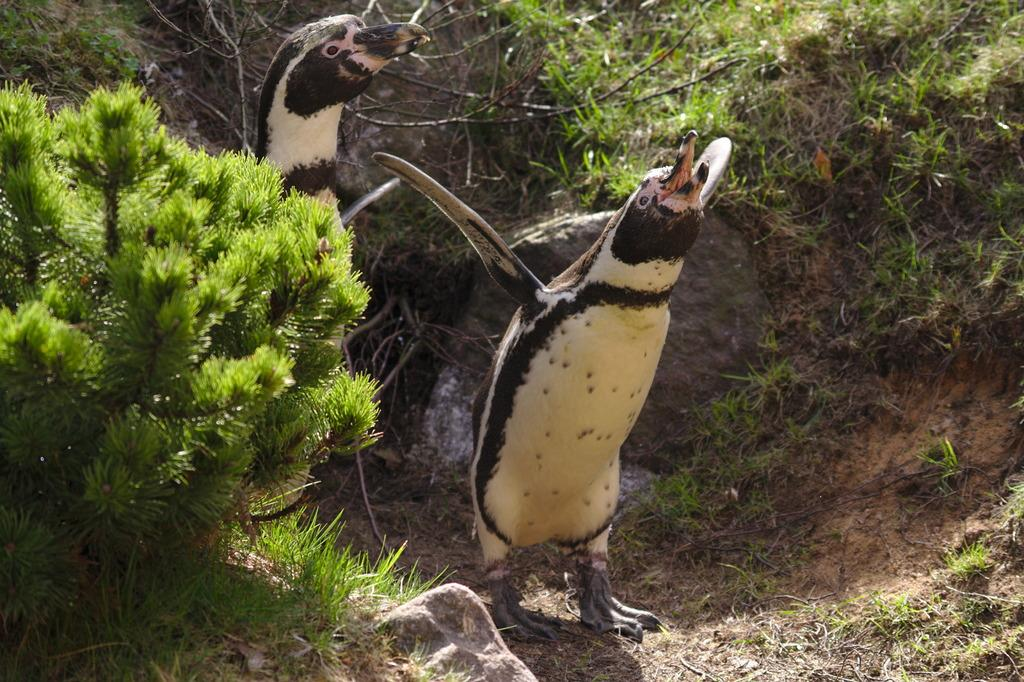How many penguins are in the image? There are 2 penguins in the image. What colors are the penguins? The penguins are white and black in color. What type of vegetation is visible in the image? There is grass and plants visible in the image. What other objects can be seen in the image? There are sticks in the image. Can you tell me how many times the penguins sneeze in the image? There is no indication of the penguins sneezing in the image, as they are not depicted in a way that suggests any action or movement. 